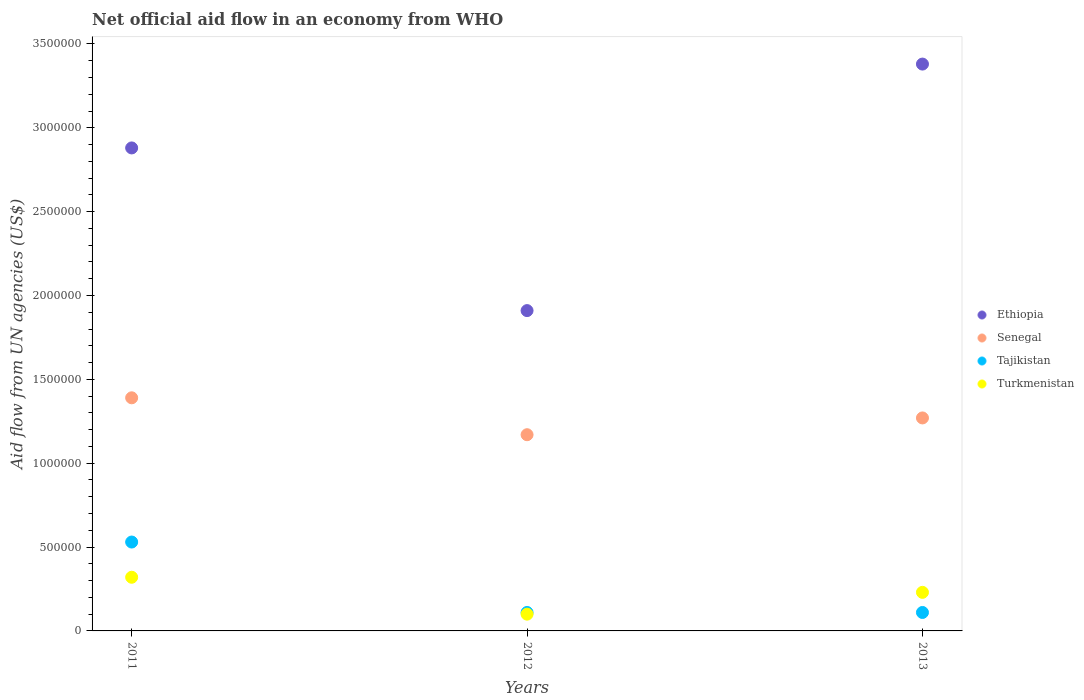Is the number of dotlines equal to the number of legend labels?
Keep it short and to the point. Yes. What is the net official aid flow in Turkmenistan in 2011?
Keep it short and to the point. 3.20e+05. Across all years, what is the minimum net official aid flow in Tajikistan?
Provide a short and direct response. 1.10e+05. In which year was the net official aid flow in Ethiopia maximum?
Keep it short and to the point. 2013. What is the total net official aid flow in Tajikistan in the graph?
Your answer should be compact. 7.50e+05. What is the difference between the net official aid flow in Tajikistan in 2011 and that in 2012?
Ensure brevity in your answer.  4.20e+05. What is the difference between the net official aid flow in Tajikistan in 2013 and the net official aid flow in Ethiopia in 2012?
Offer a terse response. -1.80e+06. What is the average net official aid flow in Senegal per year?
Offer a terse response. 1.28e+06. In the year 2013, what is the difference between the net official aid flow in Tajikistan and net official aid flow in Senegal?
Provide a succinct answer. -1.16e+06. What is the ratio of the net official aid flow in Tajikistan in 2011 to that in 2012?
Offer a terse response. 4.82. Is the net official aid flow in Turkmenistan in 2011 less than that in 2013?
Provide a succinct answer. No. Is the difference between the net official aid flow in Tajikistan in 2012 and 2013 greater than the difference between the net official aid flow in Senegal in 2012 and 2013?
Your answer should be compact. Yes. What is the difference between the highest and the second highest net official aid flow in Turkmenistan?
Your response must be concise. 9.00e+04. What is the difference between the highest and the lowest net official aid flow in Ethiopia?
Your response must be concise. 1.47e+06. In how many years, is the net official aid flow in Turkmenistan greater than the average net official aid flow in Turkmenistan taken over all years?
Provide a short and direct response. 2. Is the net official aid flow in Ethiopia strictly less than the net official aid flow in Senegal over the years?
Offer a very short reply. No. What is the difference between two consecutive major ticks on the Y-axis?
Give a very brief answer. 5.00e+05. Does the graph contain any zero values?
Your answer should be compact. No. How many legend labels are there?
Offer a terse response. 4. What is the title of the graph?
Provide a succinct answer. Net official aid flow in an economy from WHO. Does "Benin" appear as one of the legend labels in the graph?
Your answer should be very brief. No. What is the label or title of the Y-axis?
Offer a terse response. Aid flow from UN agencies (US$). What is the Aid flow from UN agencies (US$) in Ethiopia in 2011?
Your answer should be very brief. 2.88e+06. What is the Aid flow from UN agencies (US$) of Senegal in 2011?
Ensure brevity in your answer.  1.39e+06. What is the Aid flow from UN agencies (US$) of Tajikistan in 2011?
Offer a very short reply. 5.30e+05. What is the Aid flow from UN agencies (US$) of Turkmenistan in 2011?
Give a very brief answer. 3.20e+05. What is the Aid flow from UN agencies (US$) of Ethiopia in 2012?
Your answer should be compact. 1.91e+06. What is the Aid flow from UN agencies (US$) in Senegal in 2012?
Offer a very short reply. 1.17e+06. What is the Aid flow from UN agencies (US$) of Ethiopia in 2013?
Your answer should be compact. 3.38e+06. What is the Aid flow from UN agencies (US$) of Senegal in 2013?
Give a very brief answer. 1.27e+06. Across all years, what is the maximum Aid flow from UN agencies (US$) of Ethiopia?
Offer a very short reply. 3.38e+06. Across all years, what is the maximum Aid flow from UN agencies (US$) of Senegal?
Provide a succinct answer. 1.39e+06. Across all years, what is the maximum Aid flow from UN agencies (US$) of Tajikistan?
Give a very brief answer. 5.30e+05. Across all years, what is the minimum Aid flow from UN agencies (US$) in Ethiopia?
Ensure brevity in your answer.  1.91e+06. Across all years, what is the minimum Aid flow from UN agencies (US$) in Senegal?
Your response must be concise. 1.17e+06. Across all years, what is the minimum Aid flow from UN agencies (US$) in Tajikistan?
Offer a terse response. 1.10e+05. Across all years, what is the minimum Aid flow from UN agencies (US$) of Turkmenistan?
Offer a very short reply. 1.00e+05. What is the total Aid flow from UN agencies (US$) in Ethiopia in the graph?
Provide a short and direct response. 8.17e+06. What is the total Aid flow from UN agencies (US$) of Senegal in the graph?
Ensure brevity in your answer.  3.83e+06. What is the total Aid flow from UN agencies (US$) of Tajikistan in the graph?
Provide a short and direct response. 7.50e+05. What is the total Aid flow from UN agencies (US$) of Turkmenistan in the graph?
Your answer should be compact. 6.50e+05. What is the difference between the Aid flow from UN agencies (US$) in Ethiopia in 2011 and that in 2012?
Give a very brief answer. 9.70e+05. What is the difference between the Aid flow from UN agencies (US$) in Senegal in 2011 and that in 2012?
Your response must be concise. 2.20e+05. What is the difference between the Aid flow from UN agencies (US$) of Tajikistan in 2011 and that in 2012?
Your answer should be compact. 4.20e+05. What is the difference between the Aid flow from UN agencies (US$) of Turkmenistan in 2011 and that in 2012?
Your answer should be compact. 2.20e+05. What is the difference between the Aid flow from UN agencies (US$) in Ethiopia in 2011 and that in 2013?
Provide a short and direct response. -5.00e+05. What is the difference between the Aid flow from UN agencies (US$) in Senegal in 2011 and that in 2013?
Make the answer very short. 1.20e+05. What is the difference between the Aid flow from UN agencies (US$) in Turkmenistan in 2011 and that in 2013?
Ensure brevity in your answer.  9.00e+04. What is the difference between the Aid flow from UN agencies (US$) of Ethiopia in 2012 and that in 2013?
Ensure brevity in your answer.  -1.47e+06. What is the difference between the Aid flow from UN agencies (US$) of Ethiopia in 2011 and the Aid flow from UN agencies (US$) of Senegal in 2012?
Your answer should be very brief. 1.71e+06. What is the difference between the Aid flow from UN agencies (US$) of Ethiopia in 2011 and the Aid flow from UN agencies (US$) of Tajikistan in 2012?
Your response must be concise. 2.77e+06. What is the difference between the Aid flow from UN agencies (US$) in Ethiopia in 2011 and the Aid flow from UN agencies (US$) in Turkmenistan in 2012?
Provide a succinct answer. 2.78e+06. What is the difference between the Aid flow from UN agencies (US$) of Senegal in 2011 and the Aid flow from UN agencies (US$) of Tajikistan in 2012?
Ensure brevity in your answer.  1.28e+06. What is the difference between the Aid flow from UN agencies (US$) in Senegal in 2011 and the Aid flow from UN agencies (US$) in Turkmenistan in 2012?
Keep it short and to the point. 1.29e+06. What is the difference between the Aid flow from UN agencies (US$) of Ethiopia in 2011 and the Aid flow from UN agencies (US$) of Senegal in 2013?
Give a very brief answer. 1.61e+06. What is the difference between the Aid flow from UN agencies (US$) in Ethiopia in 2011 and the Aid flow from UN agencies (US$) in Tajikistan in 2013?
Give a very brief answer. 2.77e+06. What is the difference between the Aid flow from UN agencies (US$) in Ethiopia in 2011 and the Aid flow from UN agencies (US$) in Turkmenistan in 2013?
Provide a succinct answer. 2.65e+06. What is the difference between the Aid flow from UN agencies (US$) of Senegal in 2011 and the Aid flow from UN agencies (US$) of Tajikistan in 2013?
Keep it short and to the point. 1.28e+06. What is the difference between the Aid flow from UN agencies (US$) in Senegal in 2011 and the Aid flow from UN agencies (US$) in Turkmenistan in 2013?
Make the answer very short. 1.16e+06. What is the difference between the Aid flow from UN agencies (US$) of Tajikistan in 2011 and the Aid flow from UN agencies (US$) of Turkmenistan in 2013?
Give a very brief answer. 3.00e+05. What is the difference between the Aid flow from UN agencies (US$) of Ethiopia in 2012 and the Aid flow from UN agencies (US$) of Senegal in 2013?
Your response must be concise. 6.40e+05. What is the difference between the Aid flow from UN agencies (US$) in Ethiopia in 2012 and the Aid flow from UN agencies (US$) in Tajikistan in 2013?
Make the answer very short. 1.80e+06. What is the difference between the Aid flow from UN agencies (US$) in Ethiopia in 2012 and the Aid flow from UN agencies (US$) in Turkmenistan in 2013?
Your response must be concise. 1.68e+06. What is the difference between the Aid flow from UN agencies (US$) in Senegal in 2012 and the Aid flow from UN agencies (US$) in Tajikistan in 2013?
Provide a succinct answer. 1.06e+06. What is the difference between the Aid flow from UN agencies (US$) of Senegal in 2012 and the Aid flow from UN agencies (US$) of Turkmenistan in 2013?
Keep it short and to the point. 9.40e+05. What is the average Aid flow from UN agencies (US$) in Ethiopia per year?
Provide a short and direct response. 2.72e+06. What is the average Aid flow from UN agencies (US$) in Senegal per year?
Keep it short and to the point. 1.28e+06. What is the average Aid flow from UN agencies (US$) in Turkmenistan per year?
Make the answer very short. 2.17e+05. In the year 2011, what is the difference between the Aid flow from UN agencies (US$) of Ethiopia and Aid flow from UN agencies (US$) of Senegal?
Provide a succinct answer. 1.49e+06. In the year 2011, what is the difference between the Aid flow from UN agencies (US$) of Ethiopia and Aid flow from UN agencies (US$) of Tajikistan?
Ensure brevity in your answer.  2.35e+06. In the year 2011, what is the difference between the Aid flow from UN agencies (US$) of Ethiopia and Aid flow from UN agencies (US$) of Turkmenistan?
Offer a terse response. 2.56e+06. In the year 2011, what is the difference between the Aid flow from UN agencies (US$) in Senegal and Aid flow from UN agencies (US$) in Tajikistan?
Your response must be concise. 8.60e+05. In the year 2011, what is the difference between the Aid flow from UN agencies (US$) of Senegal and Aid flow from UN agencies (US$) of Turkmenistan?
Give a very brief answer. 1.07e+06. In the year 2012, what is the difference between the Aid flow from UN agencies (US$) of Ethiopia and Aid flow from UN agencies (US$) of Senegal?
Offer a terse response. 7.40e+05. In the year 2012, what is the difference between the Aid flow from UN agencies (US$) of Ethiopia and Aid flow from UN agencies (US$) of Tajikistan?
Provide a short and direct response. 1.80e+06. In the year 2012, what is the difference between the Aid flow from UN agencies (US$) of Ethiopia and Aid flow from UN agencies (US$) of Turkmenistan?
Offer a very short reply. 1.81e+06. In the year 2012, what is the difference between the Aid flow from UN agencies (US$) of Senegal and Aid flow from UN agencies (US$) of Tajikistan?
Offer a very short reply. 1.06e+06. In the year 2012, what is the difference between the Aid flow from UN agencies (US$) in Senegal and Aid flow from UN agencies (US$) in Turkmenistan?
Your answer should be very brief. 1.07e+06. In the year 2013, what is the difference between the Aid flow from UN agencies (US$) of Ethiopia and Aid flow from UN agencies (US$) of Senegal?
Ensure brevity in your answer.  2.11e+06. In the year 2013, what is the difference between the Aid flow from UN agencies (US$) in Ethiopia and Aid flow from UN agencies (US$) in Tajikistan?
Your answer should be compact. 3.27e+06. In the year 2013, what is the difference between the Aid flow from UN agencies (US$) in Ethiopia and Aid flow from UN agencies (US$) in Turkmenistan?
Offer a very short reply. 3.15e+06. In the year 2013, what is the difference between the Aid flow from UN agencies (US$) in Senegal and Aid flow from UN agencies (US$) in Tajikistan?
Give a very brief answer. 1.16e+06. In the year 2013, what is the difference between the Aid flow from UN agencies (US$) in Senegal and Aid flow from UN agencies (US$) in Turkmenistan?
Offer a terse response. 1.04e+06. What is the ratio of the Aid flow from UN agencies (US$) of Ethiopia in 2011 to that in 2012?
Offer a terse response. 1.51. What is the ratio of the Aid flow from UN agencies (US$) in Senegal in 2011 to that in 2012?
Keep it short and to the point. 1.19. What is the ratio of the Aid flow from UN agencies (US$) in Tajikistan in 2011 to that in 2012?
Offer a very short reply. 4.82. What is the ratio of the Aid flow from UN agencies (US$) of Ethiopia in 2011 to that in 2013?
Your answer should be very brief. 0.85. What is the ratio of the Aid flow from UN agencies (US$) in Senegal in 2011 to that in 2013?
Offer a terse response. 1.09. What is the ratio of the Aid flow from UN agencies (US$) in Tajikistan in 2011 to that in 2013?
Your response must be concise. 4.82. What is the ratio of the Aid flow from UN agencies (US$) of Turkmenistan in 2011 to that in 2013?
Your answer should be very brief. 1.39. What is the ratio of the Aid flow from UN agencies (US$) of Ethiopia in 2012 to that in 2013?
Your response must be concise. 0.57. What is the ratio of the Aid flow from UN agencies (US$) of Senegal in 2012 to that in 2013?
Ensure brevity in your answer.  0.92. What is the ratio of the Aid flow from UN agencies (US$) in Turkmenistan in 2012 to that in 2013?
Provide a succinct answer. 0.43. What is the difference between the highest and the second highest Aid flow from UN agencies (US$) in Ethiopia?
Ensure brevity in your answer.  5.00e+05. What is the difference between the highest and the second highest Aid flow from UN agencies (US$) in Tajikistan?
Offer a very short reply. 4.20e+05. What is the difference between the highest and the lowest Aid flow from UN agencies (US$) in Ethiopia?
Your response must be concise. 1.47e+06. What is the difference between the highest and the lowest Aid flow from UN agencies (US$) in Tajikistan?
Ensure brevity in your answer.  4.20e+05. 